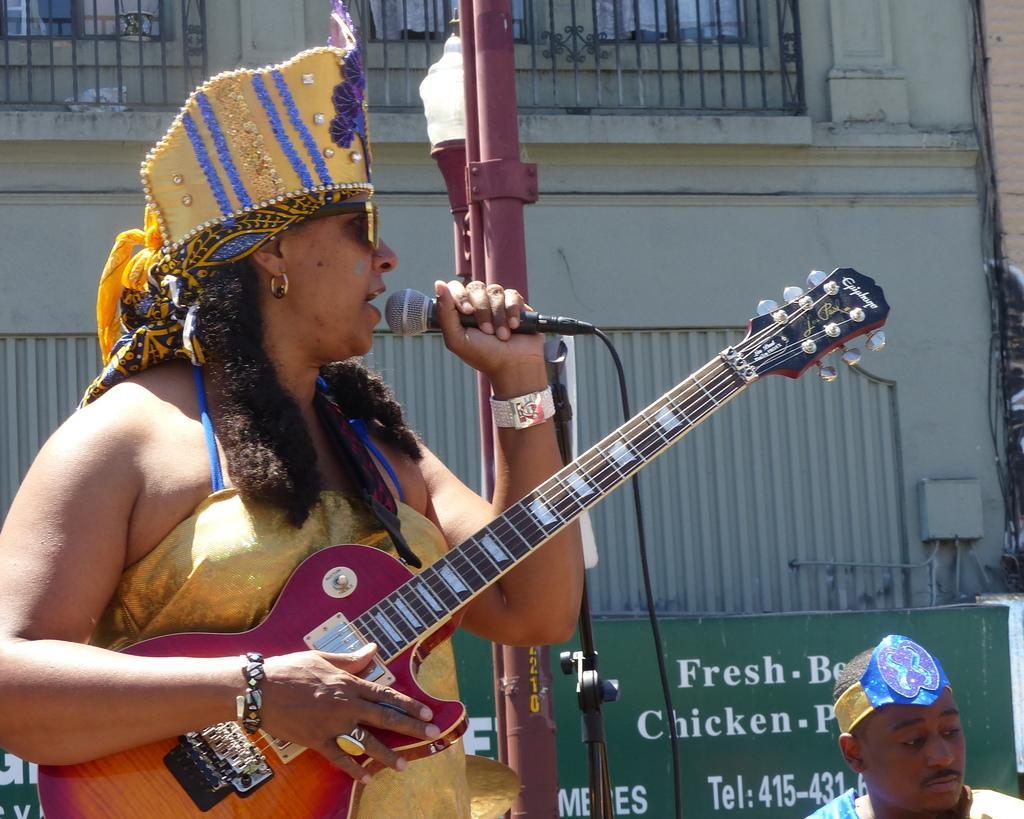Please provide a concise description of this image. In this image we can see a woman is speaking with the help of microphone and she is holding a guitar in her hand besides to her we can see a man, in the background we can see a pole, hoarding and a building. 